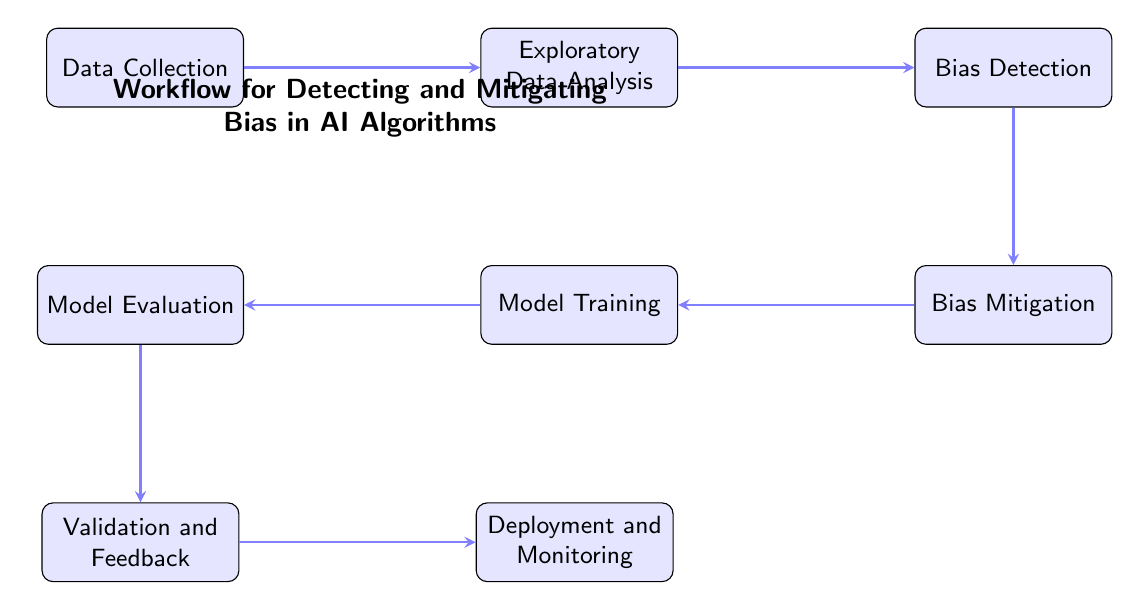What is the first node in the workflow? The diagram starts with "Data Collection" as the initial step in the workflow, which is represented as the first node.
Answer: Data Collection How many nodes are in the diagram? Counting all the distinct steps presented in the diagram, there are a total of eight nodes representing different parts of the workflow.
Answer: 8 What is the last node in the workflow? The final step shown on the diagram is "Deployment and Monitoring," which is the last node in the sequence of steps.
Answer: Deployment and Monitoring What comes after "Exploratory Data Analysis"? The flow of the diagram indicates that the step following "Exploratory Data Analysis" is "Bias Detection," showing the progression in the workflow.
Answer: Bias Detection Which step involves gathering feedback from stakeholders? In the diagram, the "Validation and Feedback" step includes the action of collecting feedback from stakeholders, making it a critical part of the evaluation process.
Answer: Validation and Feedback In which phase do you apply bias mitigation techniques? The diagram shows that bias mitigation techniques are applied in the "Bias Mitigation" phase, which directly follows bias detection in the workflow.
Answer: Bias Mitigation What metrics are used during the evaluation phase? The diagram states that during the "Model Evaluation" phase, fairness metrics like demographic parity and equal opportunity are utilized to assess the model’s performance.
Answer: Fairness metrics How many edges are present in the diagram? The diagram displays seven directed connections (edges) that represent the flow from one node to the next, illustrating the sequence of steps.
Answer: 7 What is the relationship between "Bias Detection" and "Model Training"? The diagram indicates a direct flow from "Bias Detection" to "Model Training," suggesting that detecting bias is a prerequisite for effectively training the model.
Answer: Direct flow 